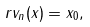<formula> <loc_0><loc_0><loc_500><loc_500>r v _ { n } ( x ) = x _ { 0 } ,</formula> 